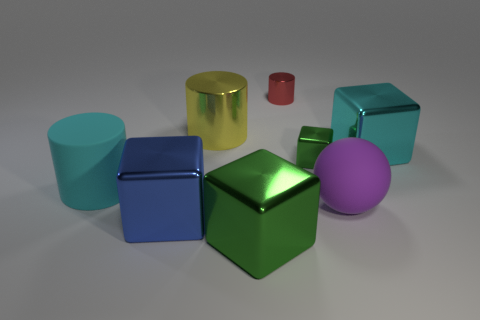Subtract all brown cylinders. Subtract all gray spheres. How many cylinders are left? 3 Add 2 red cylinders. How many objects exist? 10 Subtract all spheres. How many objects are left? 7 Subtract all small blocks. Subtract all purple objects. How many objects are left? 6 Add 8 yellow shiny cylinders. How many yellow shiny cylinders are left? 9 Add 4 blue things. How many blue things exist? 5 Subtract 1 purple spheres. How many objects are left? 7 